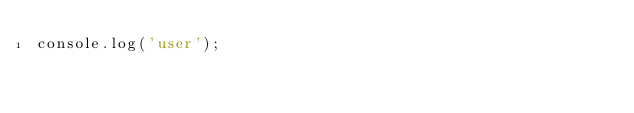<code> <loc_0><loc_0><loc_500><loc_500><_JavaScript_>console.log('user');
</code> 